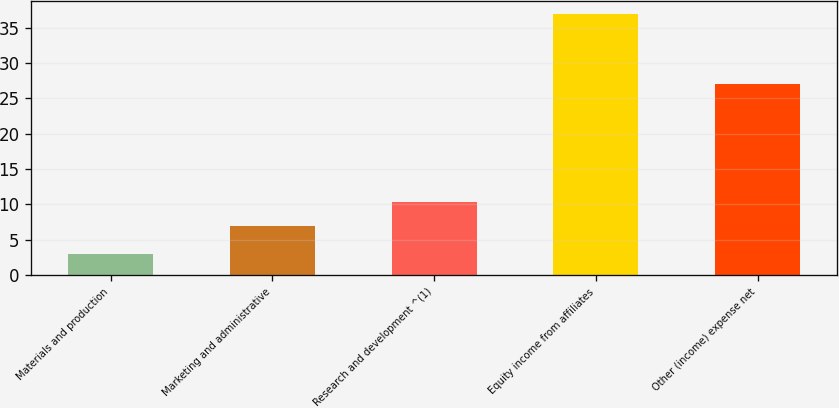Convert chart to OTSL. <chart><loc_0><loc_0><loc_500><loc_500><bar_chart><fcel>Materials and production<fcel>Marketing and administrative<fcel>Research and development ^(1)<fcel>Equity income from affiliates<fcel>Other (income) expense net<nl><fcel>3<fcel>7<fcel>10.4<fcel>37<fcel>27<nl></chart> 